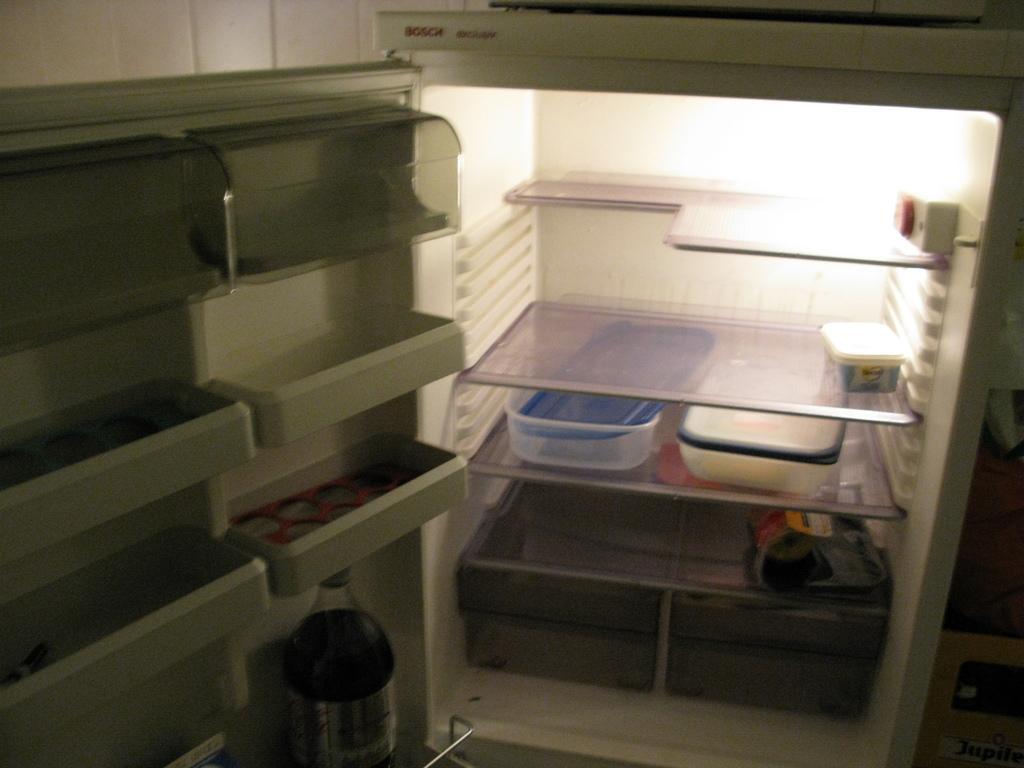Can you describe this image briefly? In the center of the image there is a refrigerator in which there are boxes. There is a bottle. There is light. 